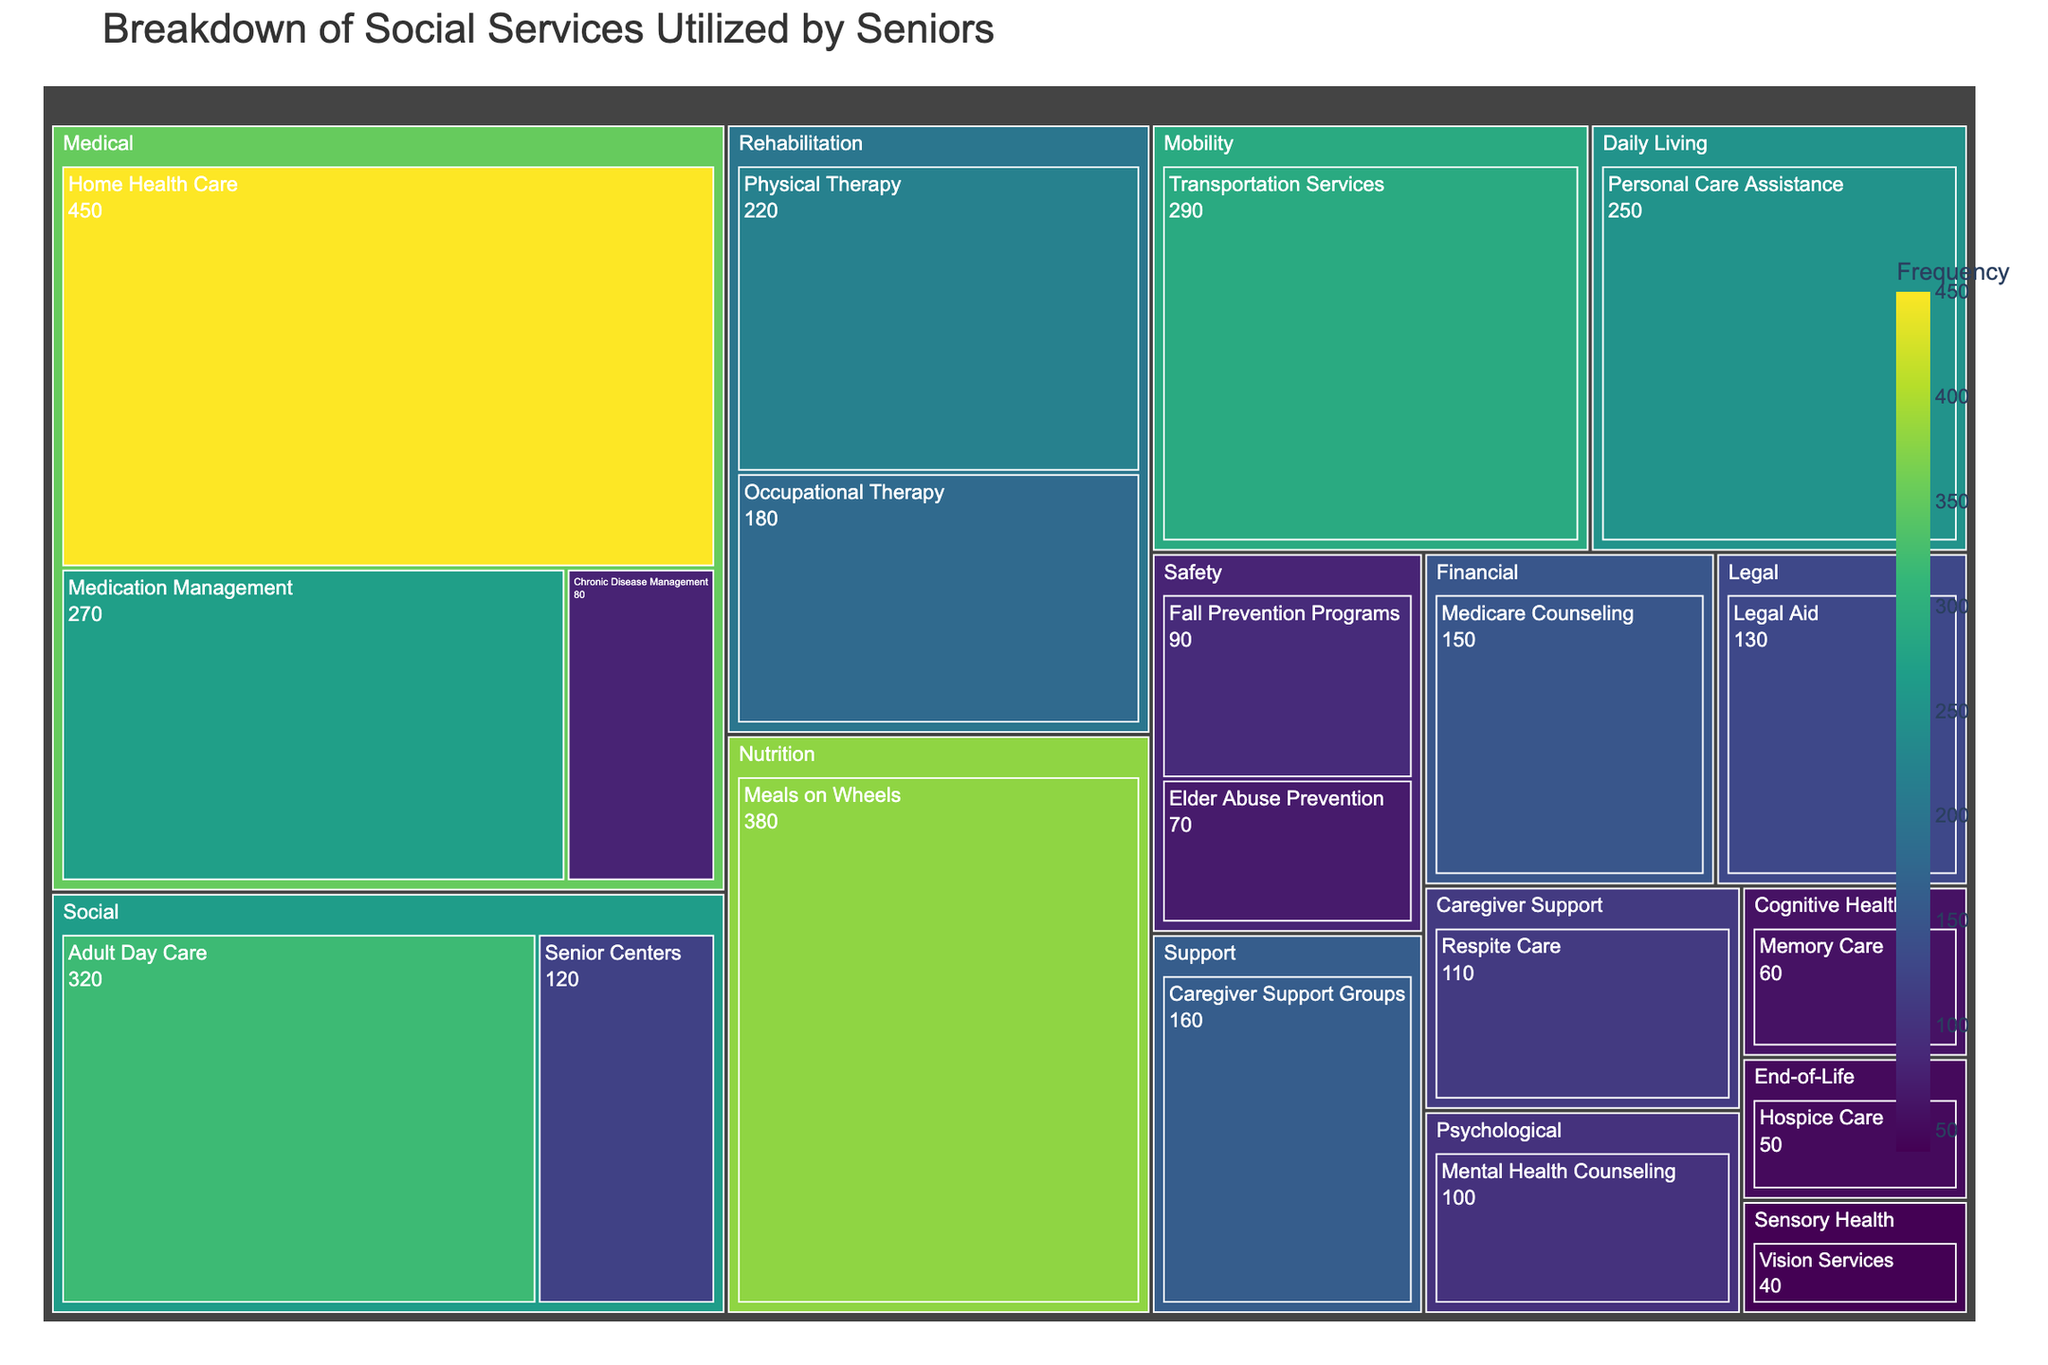What's the title of the figure? The title is typically displayed at the top of the figure. It summarizes the content of the treemap.
Answer: Breakdown of Social Services Utilized by Seniors Which service under the Medical category has the highest frequency? To answer, locate the Medical category in the treemap and identify the service within it with the largest segment.
Answer: Home Health Care What is the frequency of use for Meals on Wheels? Locate the Meals on Wheels segment in the Nutrition category in the treemap and read the frequency value displayed.
Answer: 380 How many services are listed under the category of Rehabilitation? The Rehabilitation category will show the individual segments of each service within it. Count these segments.
Answer: 2 Which categories have a frequency of less than 100 for all their services? Observe and compare each category’s segments for frequencies. Categories where all segments show values below 100 are the answer.
Answer: Safety, Cognitive Health, End-of-Life, Sensory Health What is the combined frequency of all services in the category of Daily Living? Locate the Daily Living category and sum the frequencies of all services within it: 250 (Personal Care Assistance).
Answer: 250 Which has a higher frequency, Caregiver Support Groups or Respite Care? Compare the size of the segments in the Support and Caregiver Support categories.
Answer: Caregiver Support Groups How does the frequency of Adult Day Care compare to Transportation Services? Find both services in the tree map under their respective categories and compare their frequency values (320 vs. 290).
Answer: Adult Day Care has a higher frequency What is the average frequency of services in the category of Rehabilitation? Sum the frequencies of the services in Rehabilitation (Physical Therapy - 220, Occupational Therapy - 180) and divide by the number of services. (220 + 180) / 2 = 200.
Answer: 200 Identify a category where the frequency of its services is relatively distributed and explain your reasoning. Look for a category where the segments have similar or comparable sizes. This means the services within that category are similarly utilized. For example, in Rehabilitation, the frequencies are 220 and 180, which are reasonably close.
Answer: Rehabilitation 